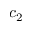Convert formula to latex. <formula><loc_0><loc_0><loc_500><loc_500>c _ { 2 }</formula> 